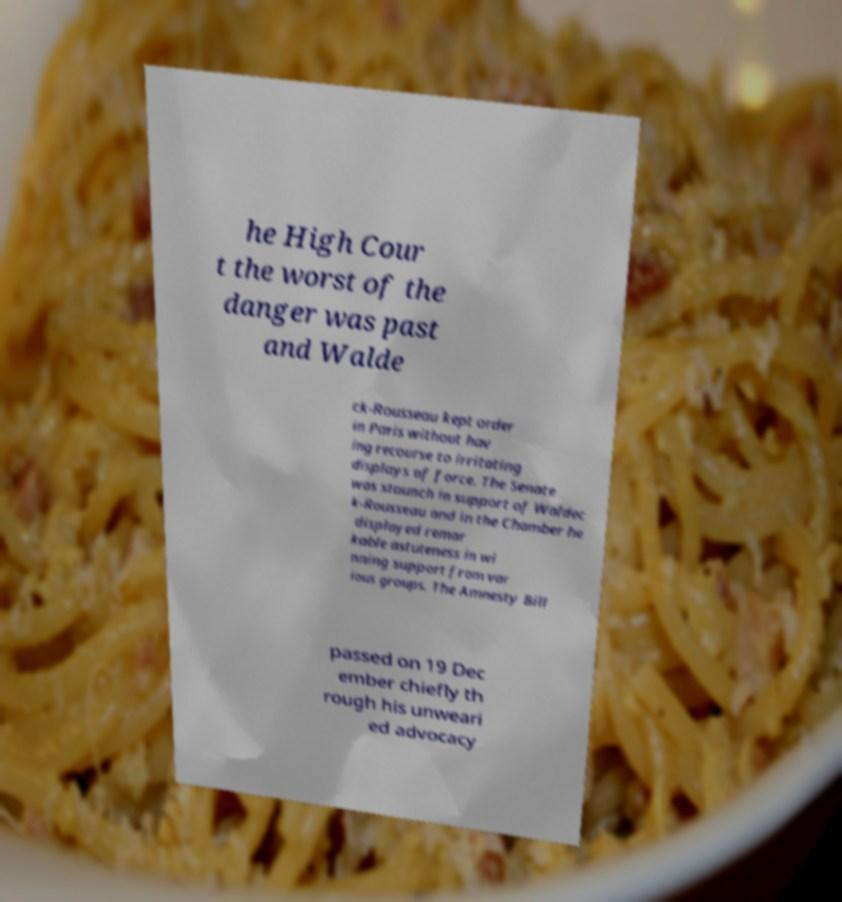Can you accurately transcribe the text from the provided image for me? he High Cour t the worst of the danger was past and Walde ck-Rousseau kept order in Paris without hav ing recourse to irritating displays of force. The Senate was staunch in support of Waldec k-Rousseau and in the Chamber he displayed remar kable astuteness in wi nning support from var ious groups. The Amnesty Bill passed on 19 Dec ember chiefly th rough his unweari ed advocacy 